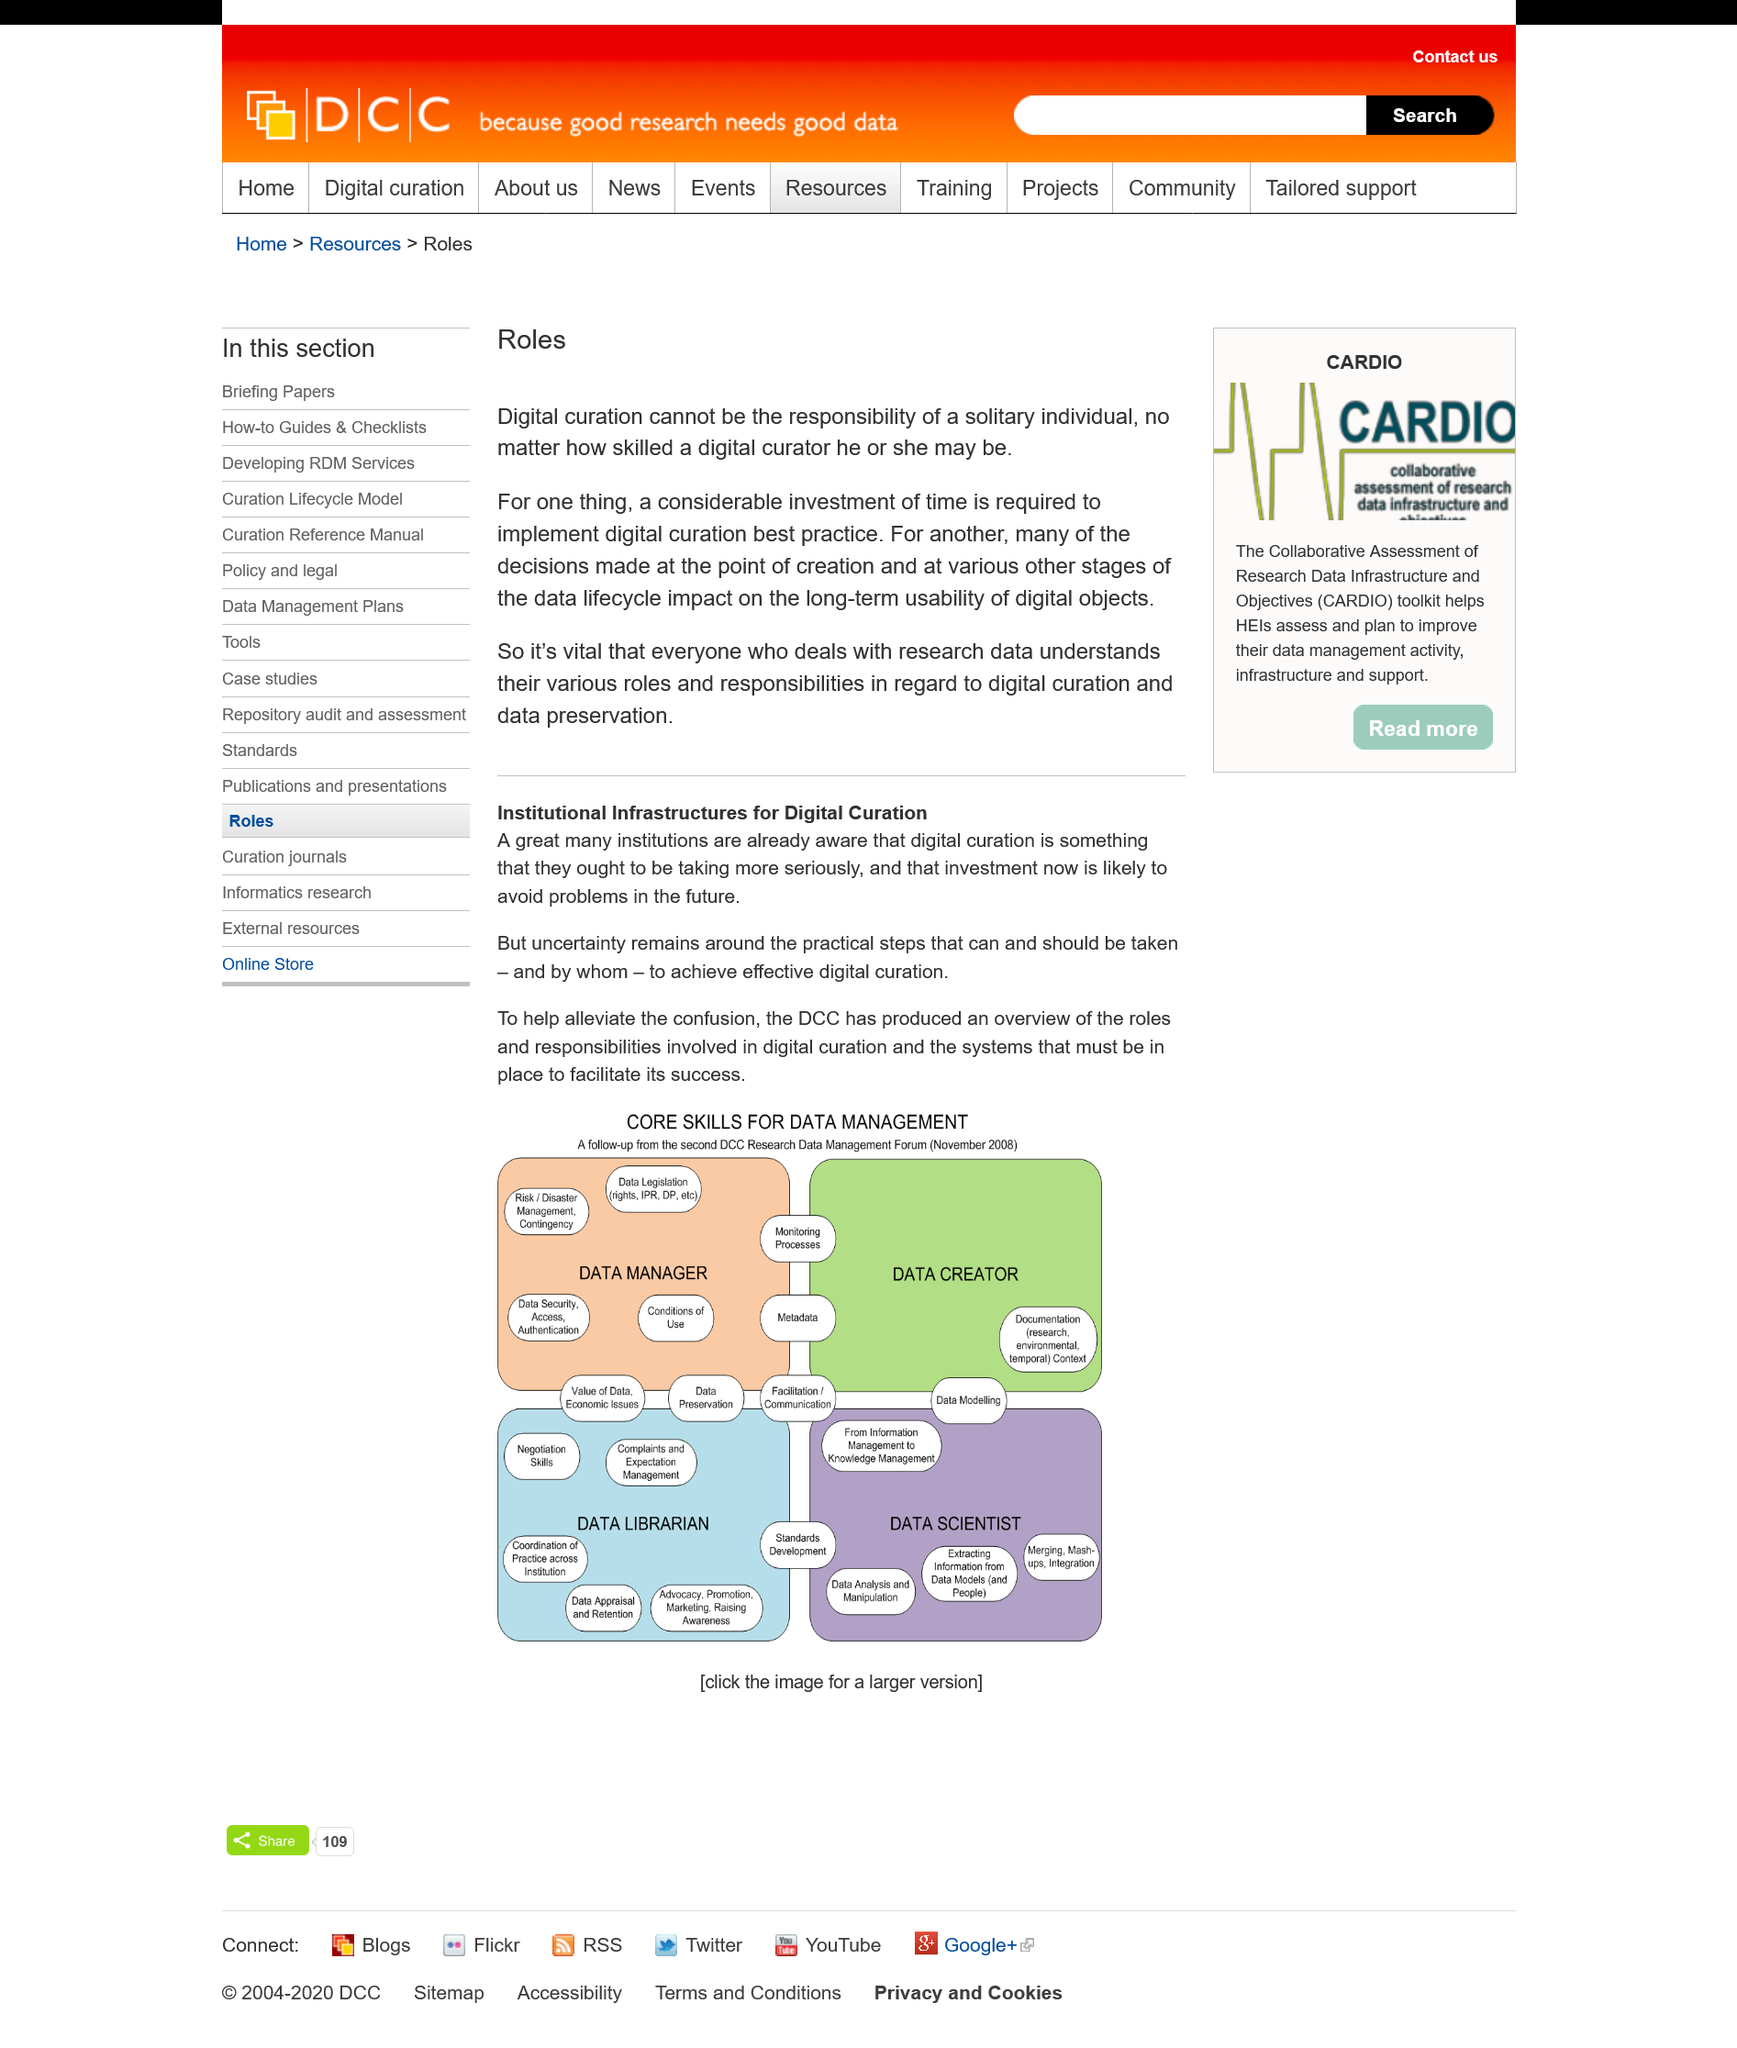Give some essential details in this illustration. It is essential for individuals involved in research data management to comprehend their respective duties and responsibilities with regards to digital curation and data preservation. The decision made at the point of creation significantly impacts the long-term usability of digital objects. Digital curation best practice requires a considerable investment of time, and this is one of the reasons why digital curation cannot be the responsibility of a solitary individual. 